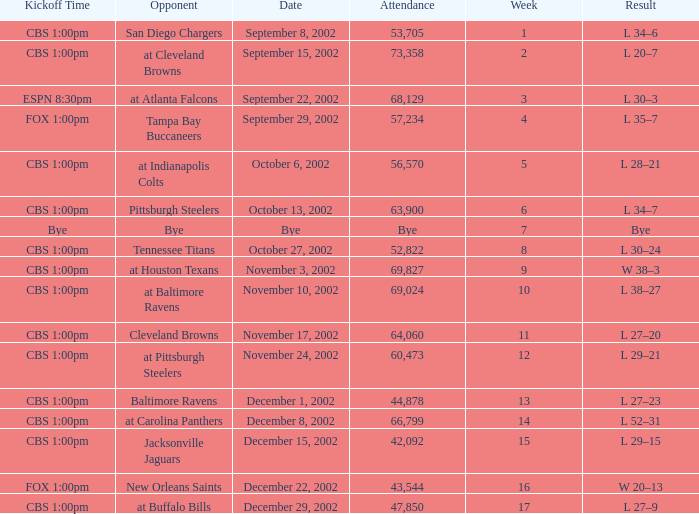What is the kickoff time for the game in week of 17? CBS 1:00pm. 